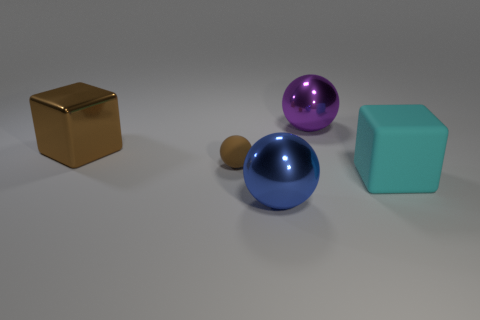Are there an equal number of large purple metal things that are in front of the tiny brown matte sphere and big metal objects behind the blue sphere?
Keep it short and to the point. No. What color is the tiny rubber thing?
Keep it short and to the point. Brown. What number of objects are big metal objects that are on the left side of the big purple ball or small brown things?
Offer a very short reply. 3. There is a matte thing to the left of the big blue metal sphere; is its size the same as the brown metal thing behind the small brown object?
Keep it short and to the point. No. How many things are either shiny things on the right side of the big brown shiny block or spheres in front of the purple sphere?
Your answer should be very brief. 3. Is the material of the blue thing the same as the large cube that is left of the small brown matte thing?
Provide a short and direct response. Yes. The big thing that is on the right side of the brown rubber ball and behind the cyan cube has what shape?
Your answer should be compact. Sphere. How many other things are there of the same color as the tiny object?
Keep it short and to the point. 1. What is the shape of the large cyan thing?
Ensure brevity in your answer.  Cube. What is the color of the sphere to the left of the metal ball that is in front of the big cyan matte thing?
Offer a very short reply. Brown. 